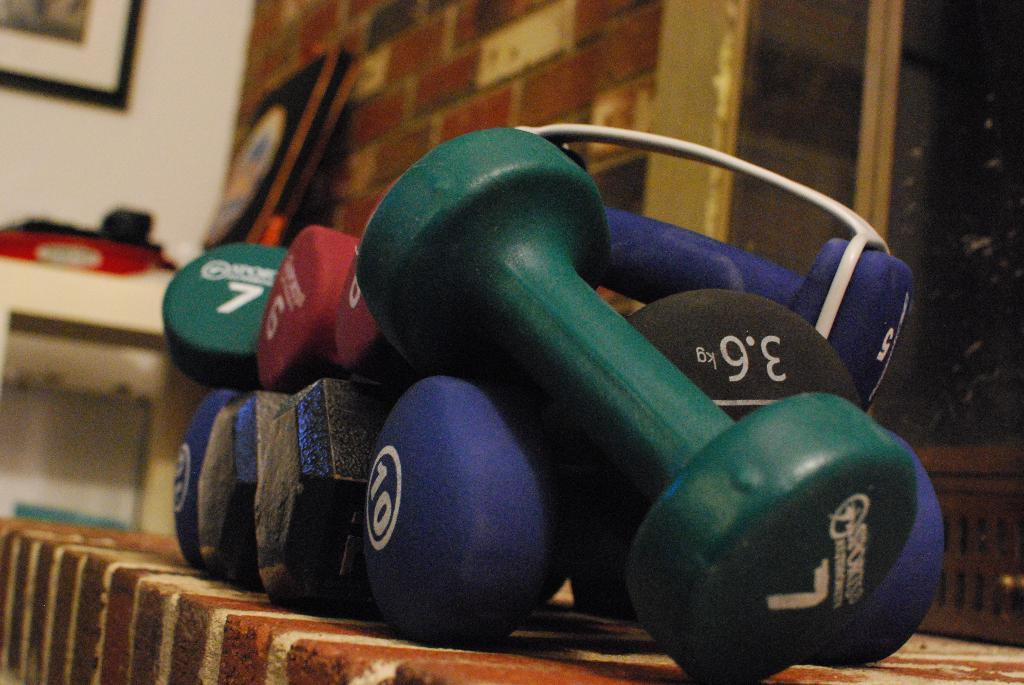What type of equipment is visible in the image? There are dumbbells in the image. What might the dumbbells be used for? The dumbbells are likely used for weightlifting or strength training exercises. How many dumbbells are present in the image? The number of dumbbells in the image cannot be determined from the provided facts. What type of steam is coming from the dumbbells in the image? There is no steam present in the image; it features dumbbells without any steam. What account might be associated with the dumbbells in the image? There is no account associated with the dumbbells in the image; they are physical equipment and not related to any accounts. 